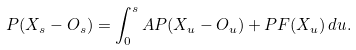<formula> <loc_0><loc_0><loc_500><loc_500>P ( X _ { s } - O _ { s } ) = \int _ { 0 } ^ { s } A P ( X _ { u } - O _ { u } ) + P F ( X _ { u } ) \, d u .</formula> 